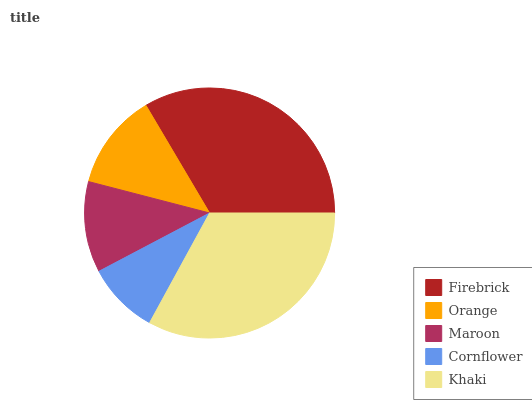Is Cornflower the minimum?
Answer yes or no. Yes. Is Firebrick the maximum?
Answer yes or no. Yes. Is Orange the minimum?
Answer yes or no. No. Is Orange the maximum?
Answer yes or no. No. Is Firebrick greater than Orange?
Answer yes or no. Yes. Is Orange less than Firebrick?
Answer yes or no. Yes. Is Orange greater than Firebrick?
Answer yes or no. No. Is Firebrick less than Orange?
Answer yes or no. No. Is Orange the high median?
Answer yes or no. Yes. Is Orange the low median?
Answer yes or no. Yes. Is Maroon the high median?
Answer yes or no. No. Is Cornflower the low median?
Answer yes or no. No. 